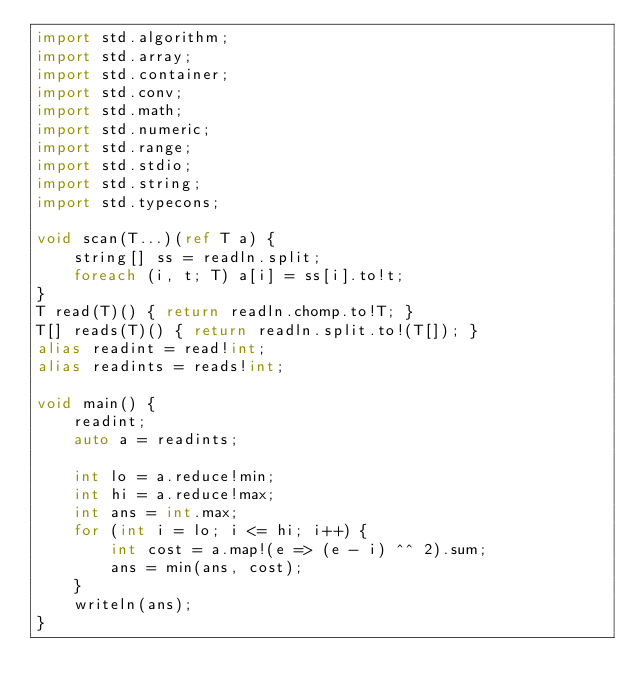Convert code to text. <code><loc_0><loc_0><loc_500><loc_500><_D_>import std.algorithm;
import std.array;
import std.container;
import std.conv;
import std.math;
import std.numeric;
import std.range;
import std.stdio;
import std.string;
import std.typecons;

void scan(T...)(ref T a) {
    string[] ss = readln.split;
    foreach (i, t; T) a[i] = ss[i].to!t;
}
T read(T)() { return readln.chomp.to!T; }
T[] reads(T)() { return readln.split.to!(T[]); }
alias readint = read!int;
alias readints = reads!int;

void main() {
    readint;
    auto a = readints;

    int lo = a.reduce!min;
    int hi = a.reduce!max;
    int ans = int.max;
    for (int i = lo; i <= hi; i++) {
        int cost = a.map!(e => (e - i) ^^ 2).sum;
        ans = min(ans, cost);
    }
    writeln(ans);
}
</code> 